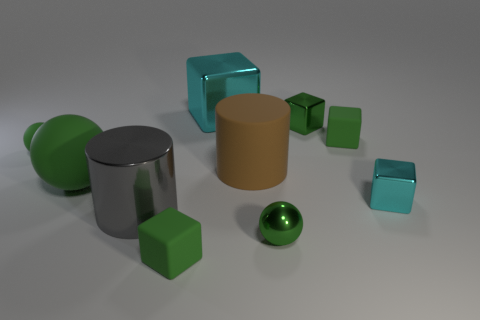How many green blocks must be subtracted to get 1 green blocks? 2 Subtract all green blocks. How many blocks are left? 2 Subtract all small green metal balls. How many balls are left? 2 Subtract 1 brown cylinders. How many objects are left? 9 Subtract all spheres. How many objects are left? 7 Subtract 5 blocks. How many blocks are left? 0 Subtract all yellow cubes. Subtract all purple spheres. How many cubes are left? 5 Subtract all gray balls. How many brown cylinders are left? 1 Subtract all big brown rubber cylinders. Subtract all large objects. How many objects are left? 5 Add 5 small cyan shiny blocks. How many small cyan shiny blocks are left? 6 